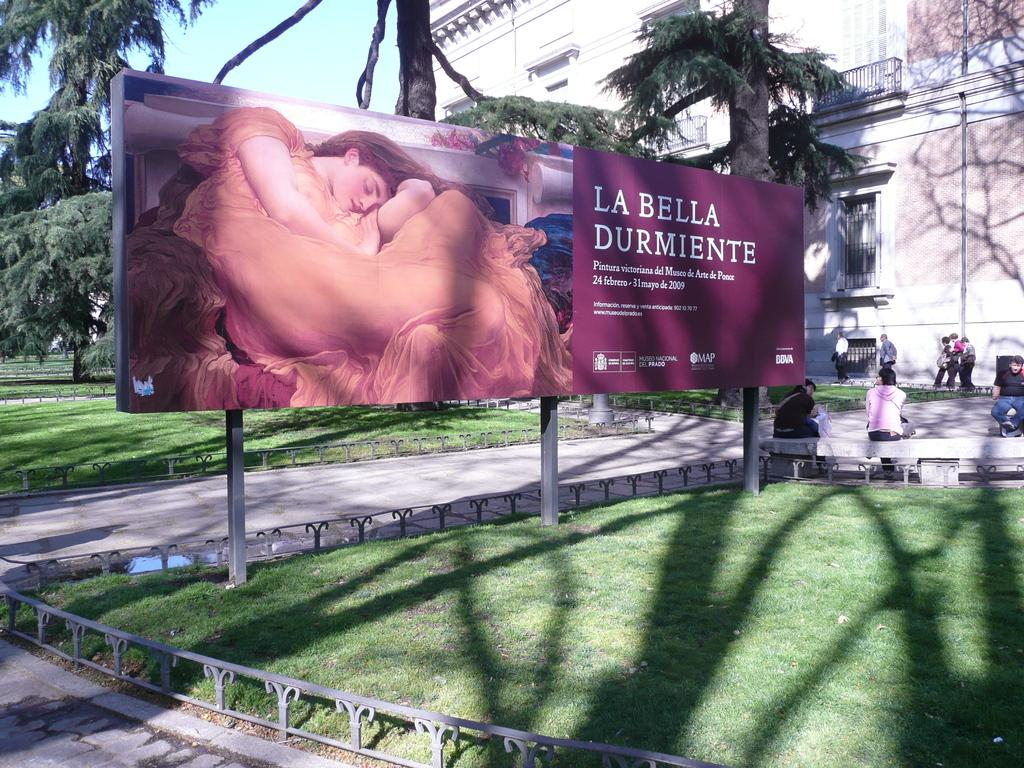<image>
Offer a succinct explanation of the picture presented. A large billboard ad for La Bella Durmiente 